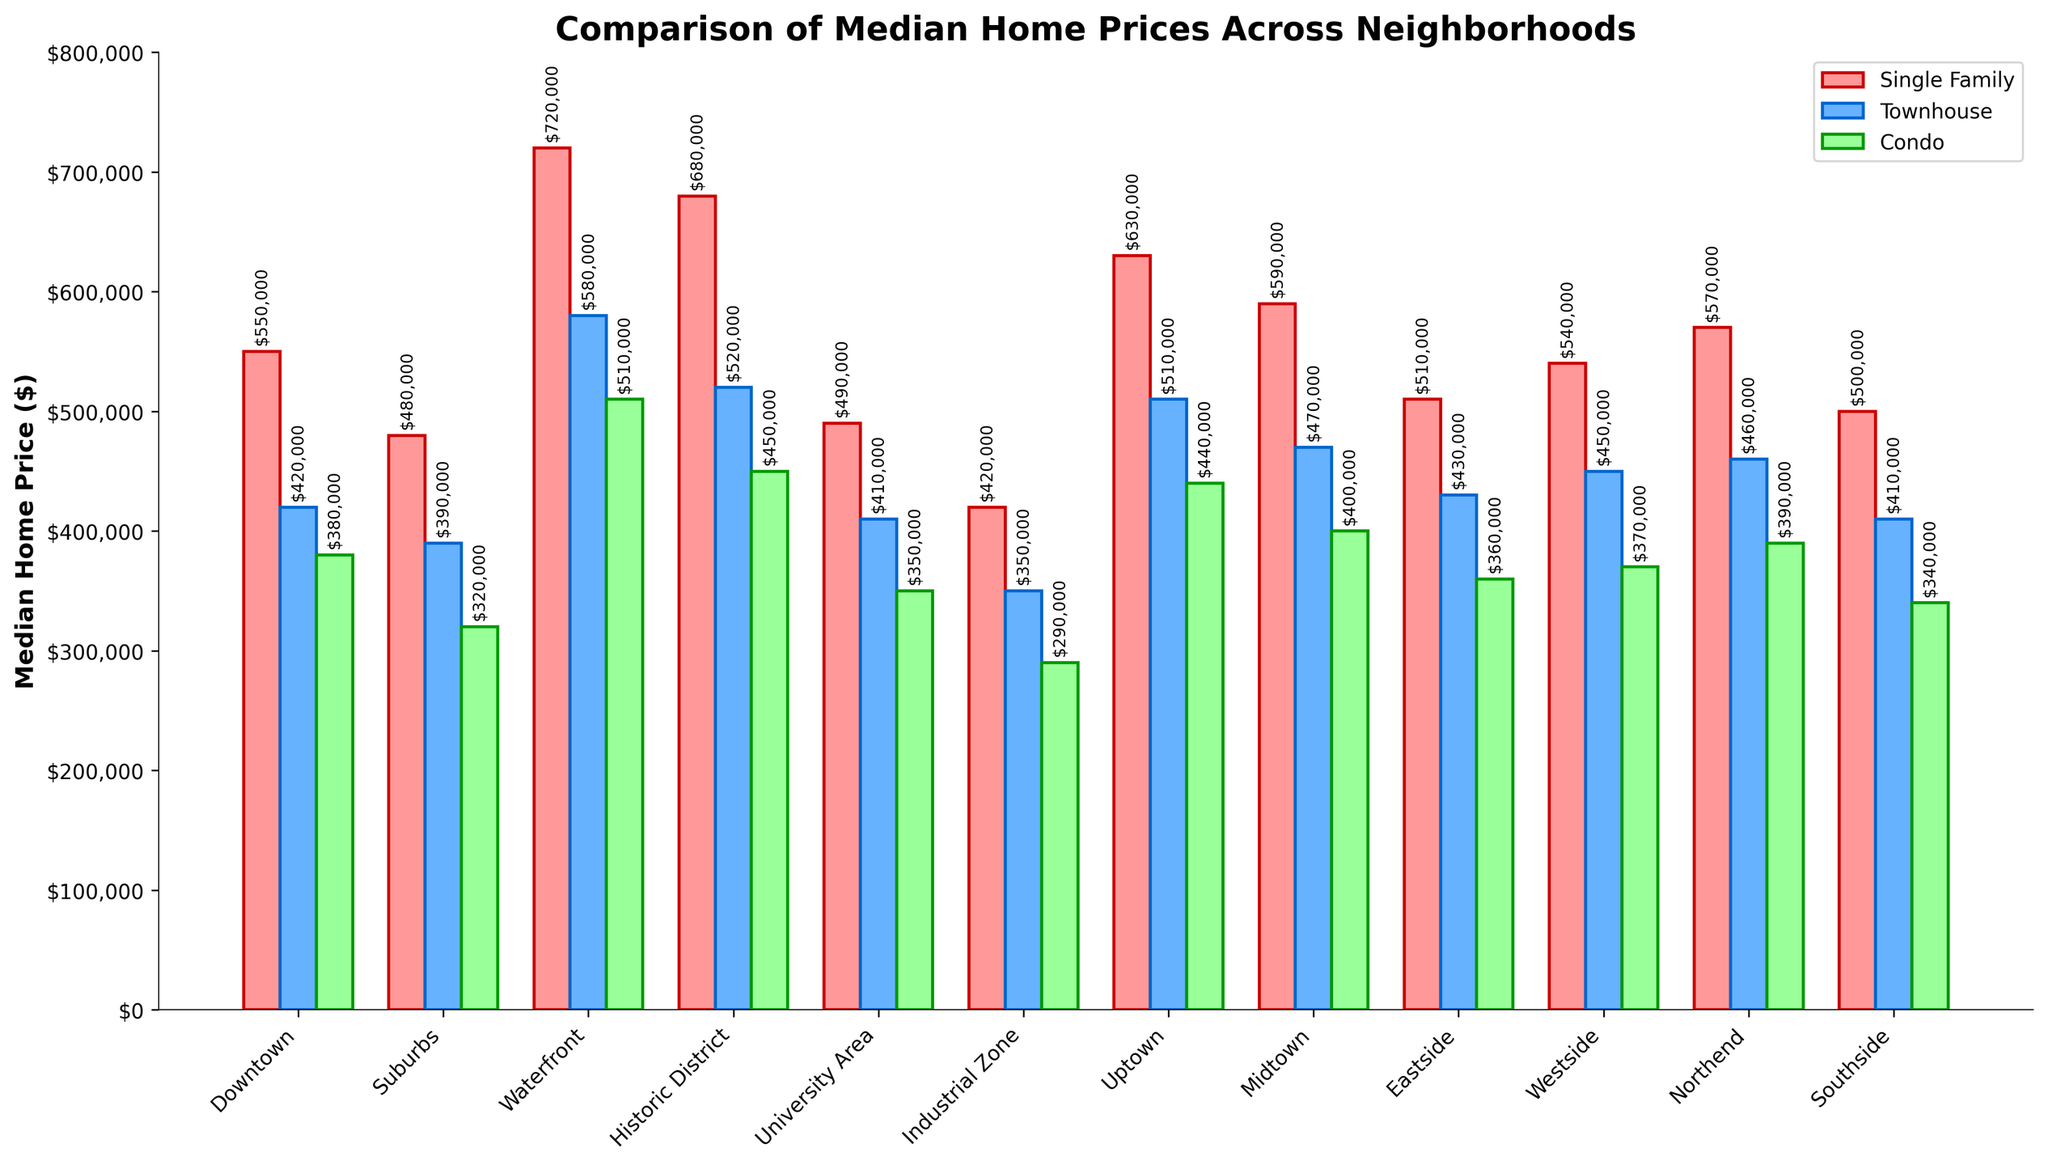Which neighborhood has the highest median home price for single-family homes? The highest median home price for single-family homes can be identified by looking for the tallest red bar in the chart. The tallest red bar corresponds to the Waterfront neighborhood.
Answer: Waterfront What is the difference between the median home price of a townhouse in Midtown and Downtown? To find the difference, look at the heights of the blue bars for townhouses in Midtown ($470,000) and Downtown ($420,000) and subtract the latter from the former. $470,000 - $420,000 = $50,000.
Answer: $50,000 Which neighborhoods have a median home price for condos less than $350,000? To find this, identify the neighborhoods where the green bar for condos is below $350,000. This applies to Industrial Zone ($290,000) and Suburbs ($320,000).
Answer: Industrial Zone, Suburbs What is the average median home price for single-family homes in Waterfront and Historic District? First, find the median home prices for single-family homes in Waterfront ($720,000) and Historic District ($680,000). Sum them up and divide by 2: ($720,000 + $680,000) / 2 = $700,000.
Answer: $700,000 Is the median home price of a condo higher in Uptown or Eastside? Compare the height of the green bars for condos in Uptown ($440,000) and Eastside ($360,000). The condo price is higher in Uptown.
Answer: Uptown Which property type has the lowest median home price in the Southside neighborhood? Examine the heights of the bars in the Southside neighborhood section. The green bar (condo) is the shortest at $340,000, indicating the lowest median home price.
Answer: Condo What is the combined median home price of a single-family home in Uptown and a townhouse in Suburbs? Find the individual median home prices: Uptown single-family home ($630,000) and Suburbs townhouse ($390,000). Add them together: $630,000 + $390,000 = $1,020,000.
Answer: $1,020,000 How much more expensive is a single-family home in Waterfront compared to University Area? Look at the median prices for single-family homes in Waterfront ($720,000) and University Area ($490,000). Subtract the latter from the former: $720,000 - $490,000 = $230,000.
Answer: $230,000 Which neighborhood shows the highest median home price disparity between single-family homes and condos? Calculate the price disparities by subtracting the condo price from the single-family home price for each neighborhood, and find the maximum value: 
- Downtown: $550,000 - $380,000 = $170,000
- Suburbs: $480,000 - $320,000 = $160,000
- Waterfront: $720,000 - $510,000 = $210,000
- Historic District: $680,000 - $450,000 = $230,000
- University Area: $490,000 - $350,000 = $140,000
- Industrial Zone: $420,000 - $290,000 = $130,000
- Uptown: $630,000 - $440,000 = $190,000
- Midtown: $590,000 - $400,000 = $190,000
- Eastside: $510,000 - $360,000 = $150,000
- Westside: $540,000 - $370,000 = $170,000
- Northend: $570,000 - $390,000 = $180,000
- Southside: $500,000 - $340,000 = $160,000
Hence, Historic District has the highest disparity at $230,000.
Answer: Historic District 